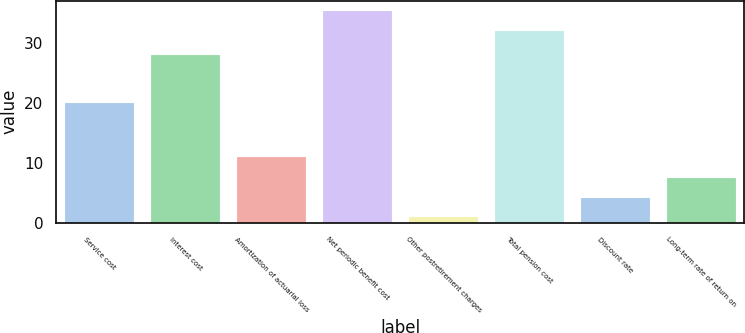Convert chart. <chart><loc_0><loc_0><loc_500><loc_500><bar_chart><fcel>Service cost<fcel>Interest cost<fcel>Amortization of actuarial loss<fcel>Net periodic benefit cost<fcel>Other postretirement charges<fcel>Total pension cost<fcel>Discount rate<fcel>Long-term rate of return on<nl><fcel>20<fcel>28<fcel>11<fcel>35.2<fcel>1<fcel>32<fcel>4.2<fcel>7.4<nl></chart> 